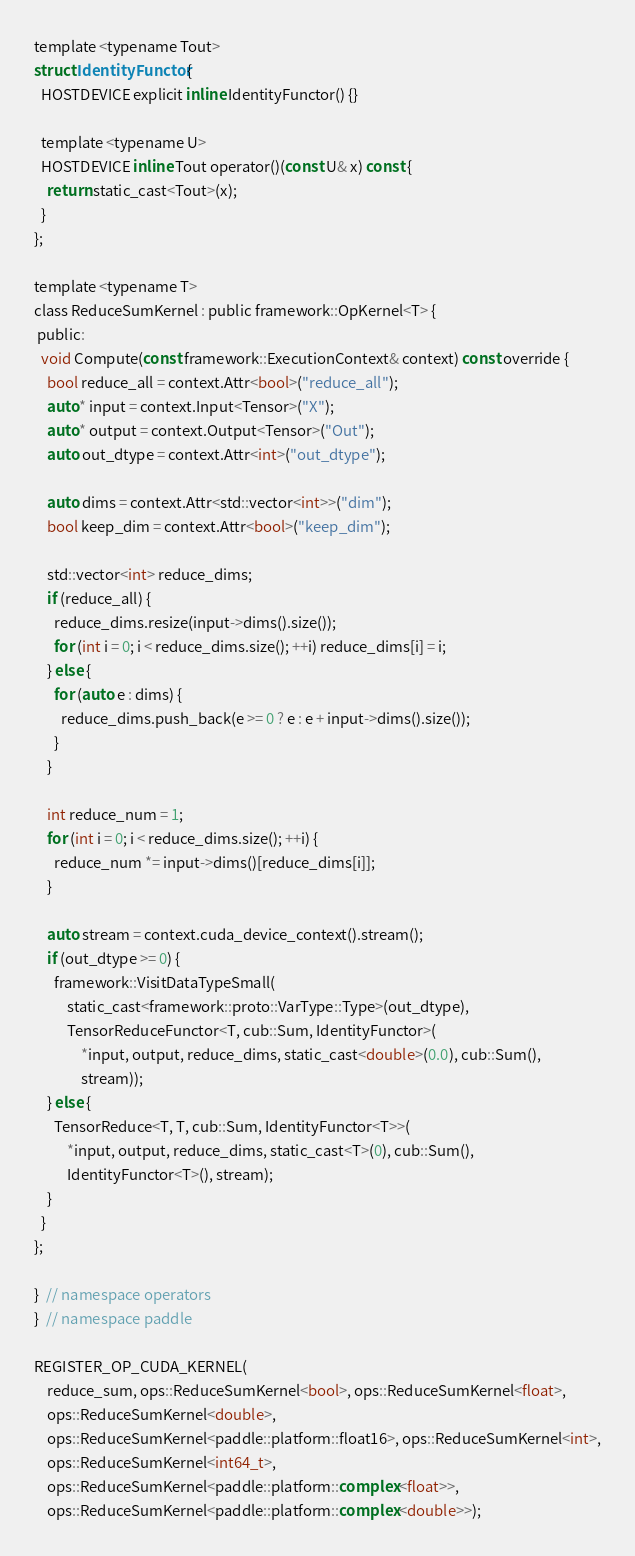Convert code to text. <code><loc_0><loc_0><loc_500><loc_500><_Cuda_>
template <typename Tout>
struct IdentityFunctor {
  HOSTDEVICE explicit inline IdentityFunctor() {}

  template <typename U>
  HOSTDEVICE inline Tout operator()(const U& x) const {
    return static_cast<Tout>(x);
  }
};

template <typename T>
class ReduceSumKernel : public framework::OpKernel<T> {
 public:
  void Compute(const framework::ExecutionContext& context) const override {
    bool reduce_all = context.Attr<bool>("reduce_all");
    auto* input = context.Input<Tensor>("X");
    auto* output = context.Output<Tensor>("Out");
    auto out_dtype = context.Attr<int>("out_dtype");

    auto dims = context.Attr<std::vector<int>>("dim");
    bool keep_dim = context.Attr<bool>("keep_dim");

    std::vector<int> reduce_dims;
    if (reduce_all) {
      reduce_dims.resize(input->dims().size());
      for (int i = 0; i < reduce_dims.size(); ++i) reduce_dims[i] = i;
    } else {
      for (auto e : dims) {
        reduce_dims.push_back(e >= 0 ? e : e + input->dims().size());
      }
    }

    int reduce_num = 1;
    for (int i = 0; i < reduce_dims.size(); ++i) {
      reduce_num *= input->dims()[reduce_dims[i]];
    }

    auto stream = context.cuda_device_context().stream();
    if (out_dtype >= 0) {
      framework::VisitDataTypeSmall(
          static_cast<framework::proto::VarType::Type>(out_dtype),
          TensorReduceFunctor<T, cub::Sum, IdentityFunctor>(
              *input, output, reduce_dims, static_cast<double>(0.0), cub::Sum(),
              stream));
    } else {
      TensorReduce<T, T, cub::Sum, IdentityFunctor<T>>(
          *input, output, reduce_dims, static_cast<T>(0), cub::Sum(),
          IdentityFunctor<T>(), stream);
    }
  }
};

}  // namespace operators
}  // namespace paddle

REGISTER_OP_CUDA_KERNEL(
    reduce_sum, ops::ReduceSumKernel<bool>, ops::ReduceSumKernel<float>,
    ops::ReduceSumKernel<double>,
    ops::ReduceSumKernel<paddle::platform::float16>, ops::ReduceSumKernel<int>,
    ops::ReduceSumKernel<int64_t>,
    ops::ReduceSumKernel<paddle::platform::complex<float>>,
    ops::ReduceSumKernel<paddle::platform::complex<double>>);
</code> 